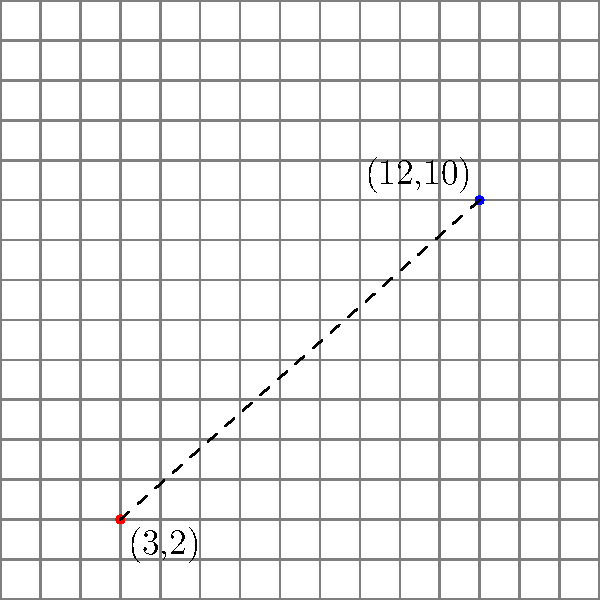On a Scrabble board, a player is considering placing a word between two coordinates: (3,2) and (12,10). To determine the optimal word placement, the player needs to calculate the distance between these two points. Using the distance formula, calculate the distance between the coordinates (3,2) and (12,10) on the Scrabble board. Round your answer to two decimal places. To solve this problem, we'll use the distance formula between two points in a two-dimensional plane:

$$d = \sqrt{(x_2 - x_1)^2 + (y_2 - y_1)^2}$$

Where $(x_1, y_1)$ is the first point and $(x_2, y_2)$ is the second point.

Step 1: Identify the coordinates
- Point 1: $(x_1, y_1) = (3, 2)$
- Point 2: $(x_2, y_2) = (12, 10)$

Step 2: Plug the values into the distance formula
$$d = \sqrt{(12 - 3)^2 + (10 - 2)^2}$$

Step 3: Simplify the expressions inside the parentheses
$$d = \sqrt{9^2 + 8^2}$$

Step 4: Calculate the squares
$$d = \sqrt{81 + 64}$$

Step 5: Add the values under the square root
$$d = \sqrt{145}$$

Step 6: Calculate the square root and round to two decimal places
$$d \approx 12.04$$

Therefore, the distance between the two coordinates on the Scrabble board is approximately 12.04 units.
Answer: 12.04 units 